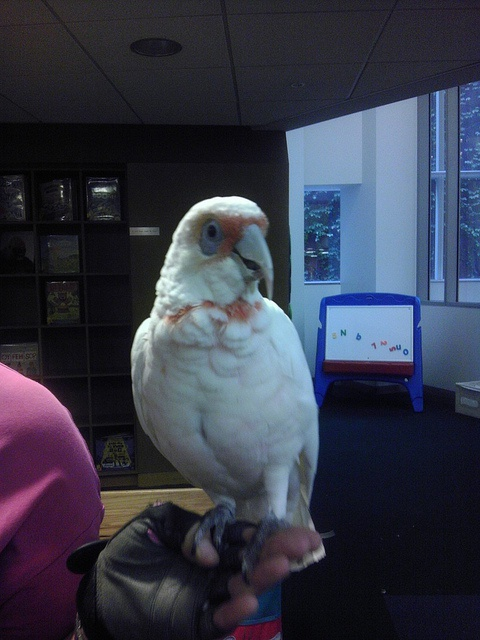Describe the objects in this image and their specific colors. I can see bird in black, gray, and darkgray tones, people in black, purple, and gray tones, tv in black, lightblue, and darkblue tones, and book in black and purple tones in this image. 